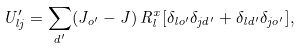Convert formula to latex. <formula><loc_0><loc_0><loc_500><loc_500>U ^ { \prime } _ { l j } = \sum _ { d ^ { \prime } } ( J _ { o ^ { \prime } } - J ) \, R _ { l } ^ { x } [ \delta _ { l o ^ { \prime } } \delta _ { j d ^ { \prime } } + \delta _ { l d ^ { \prime } } \delta _ { j o ^ { \prime } } ] ,</formula> 